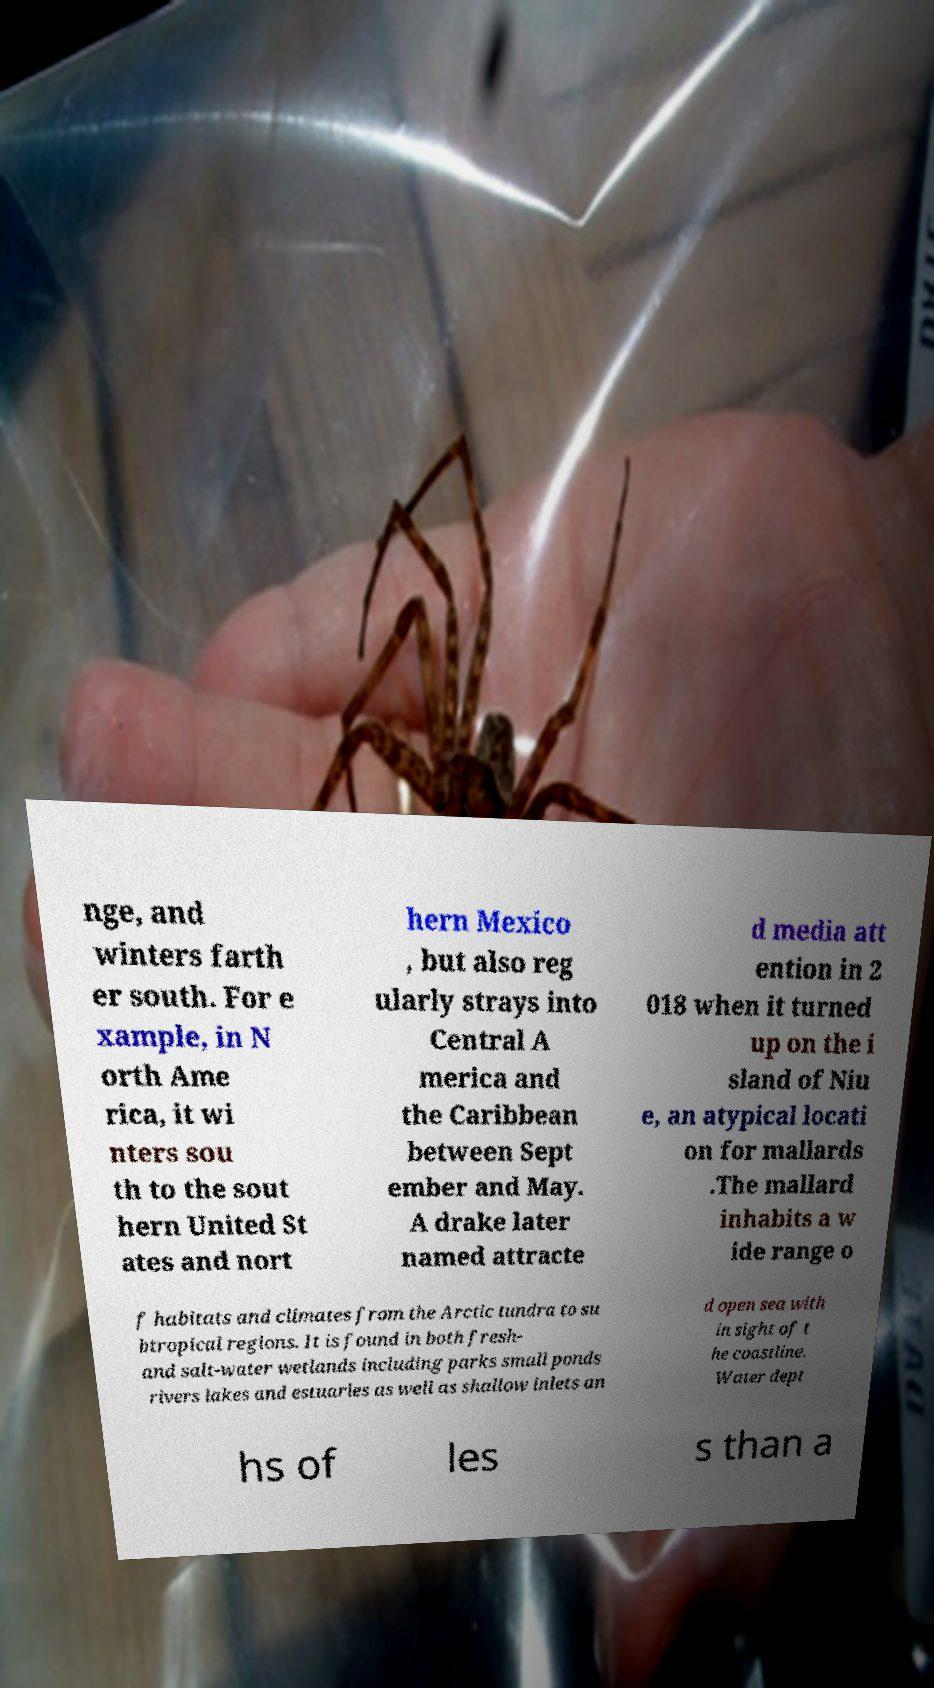Please identify and transcribe the text found in this image. nge, and winters farth er south. For e xample, in N orth Ame rica, it wi nters sou th to the sout hern United St ates and nort hern Mexico , but also reg ularly strays into Central A merica and the Caribbean between Sept ember and May. A drake later named attracte d media att ention in 2 018 when it turned up on the i sland of Niu e, an atypical locati on for mallards .The mallard inhabits a w ide range o f habitats and climates from the Arctic tundra to su btropical regions. It is found in both fresh- and salt-water wetlands including parks small ponds rivers lakes and estuaries as well as shallow inlets an d open sea with in sight of t he coastline. Water dept hs of les s than a 